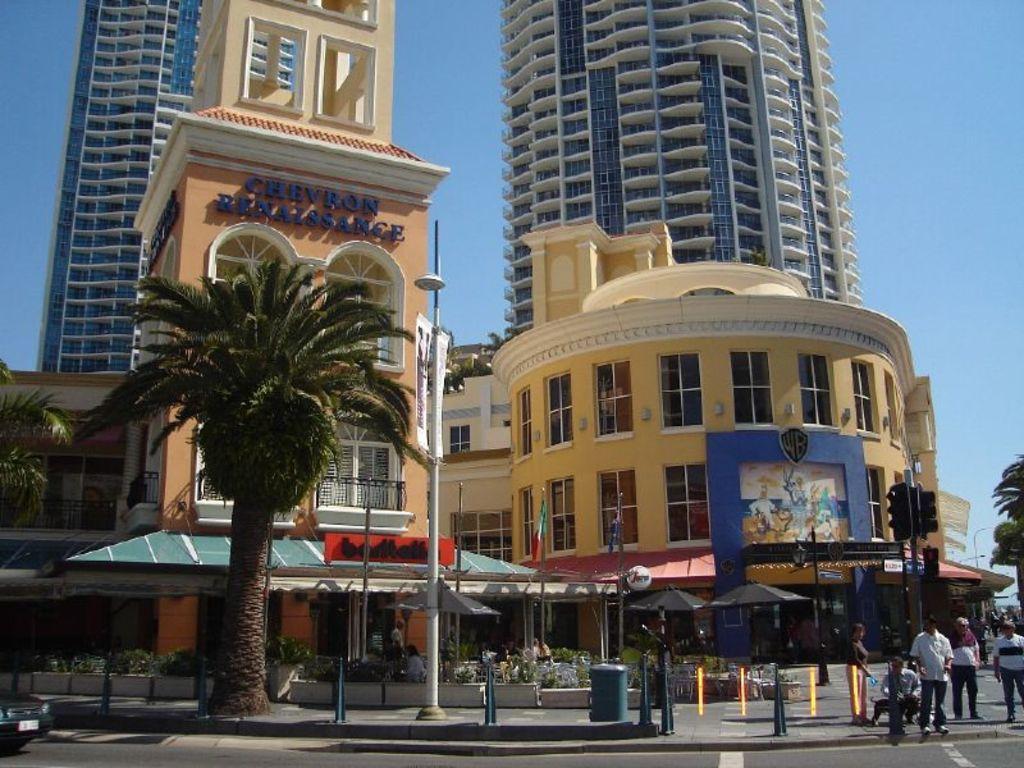In one or two sentences, can you explain what this image depicts? In this image I can see a road in the front and on the left side I can see a vehicle on it. I can also see few trees, few poles, few signal lights and on the right side I can see few people are standing. In the background I can see few buildings, the sky and on the left side of this image I can see something is written on the building. 